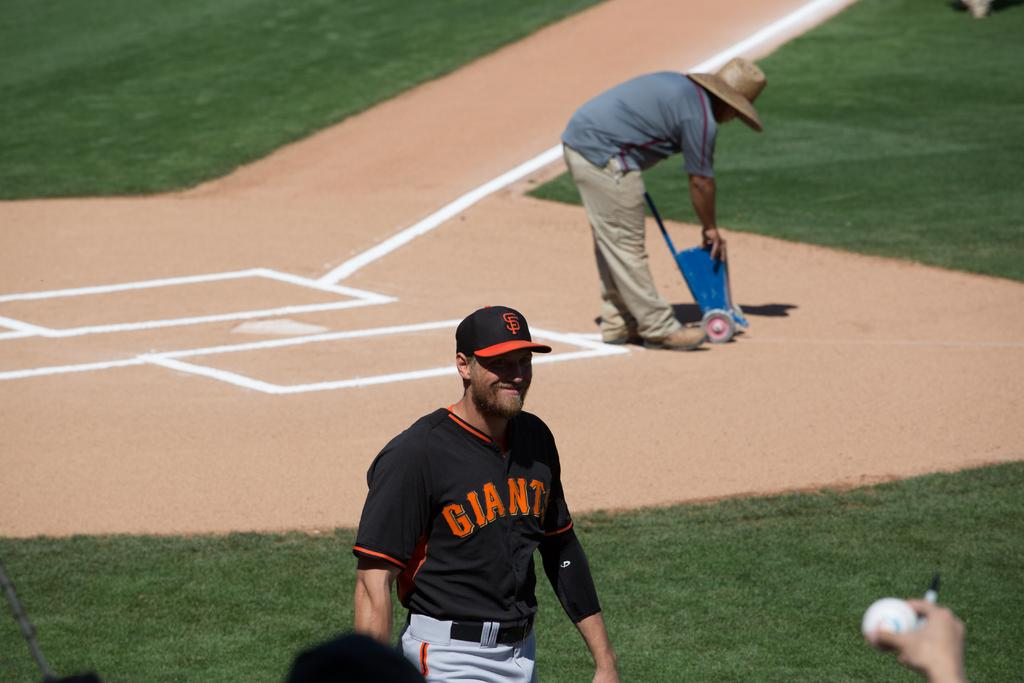<image>
Render a clear and concise summary of the photo. A baseball player with a Giants jersey on with a man in a sun hat and blue shirt bending down behind him. 